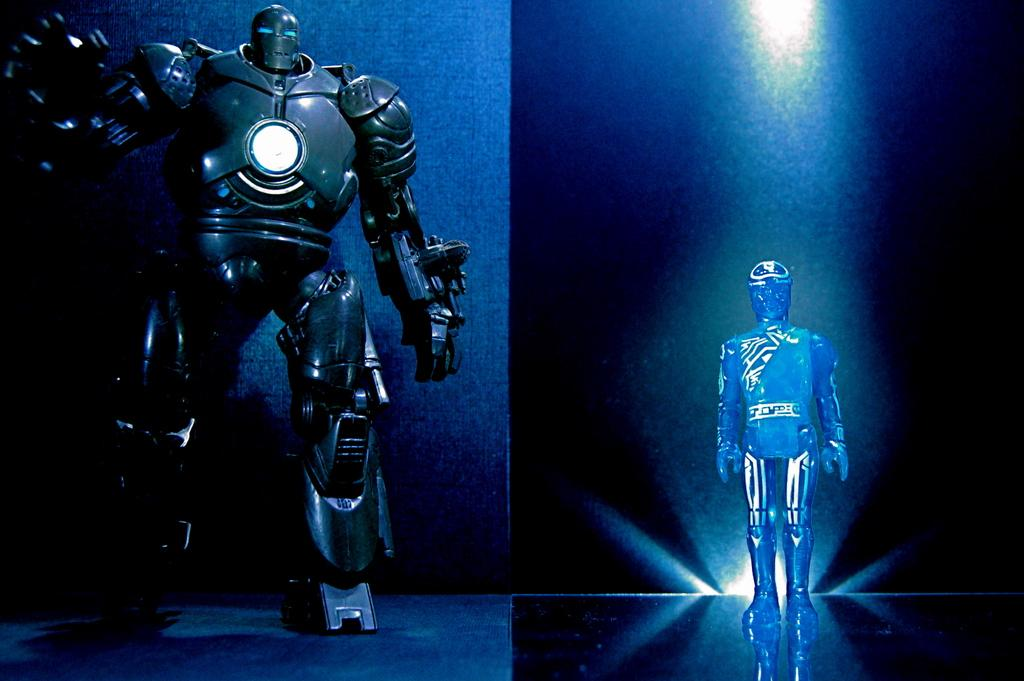What type of machines are present in the image? There are robotic machines in the image. What is the position of the robotic machines? The robotic machines are standing. What type of pain is the robotic machine experiencing in the image? Robotic machines do not experience pain, as they are machines and not living beings. 